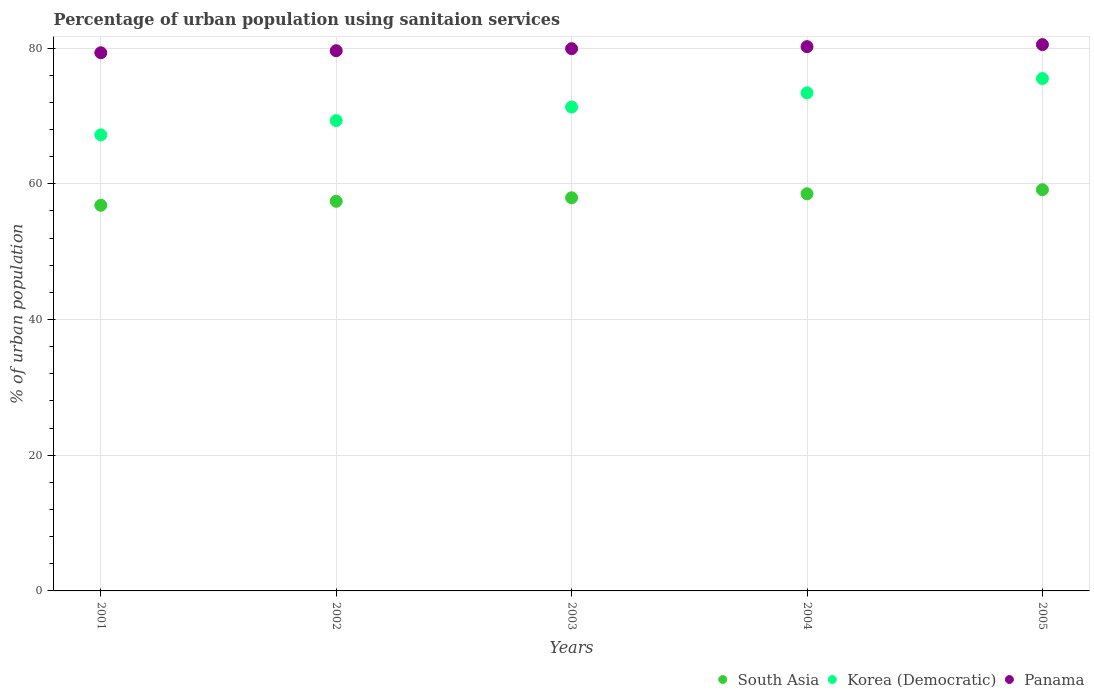How many different coloured dotlines are there?
Keep it short and to the point. 3. Is the number of dotlines equal to the number of legend labels?
Give a very brief answer. Yes. What is the percentage of urban population using sanitaion services in South Asia in 2002?
Your answer should be compact. 57.41. Across all years, what is the maximum percentage of urban population using sanitaion services in South Asia?
Offer a very short reply. 59.12. Across all years, what is the minimum percentage of urban population using sanitaion services in Panama?
Provide a succinct answer. 79.3. In which year was the percentage of urban population using sanitaion services in Panama maximum?
Offer a terse response. 2005. What is the total percentage of urban population using sanitaion services in Panama in the graph?
Provide a short and direct response. 399.5. What is the difference between the percentage of urban population using sanitaion services in South Asia in 2002 and that in 2005?
Your answer should be very brief. -1.71. What is the difference between the percentage of urban population using sanitaion services in South Asia in 2002 and the percentage of urban population using sanitaion services in Korea (Democratic) in 2005?
Your answer should be very brief. -18.09. What is the average percentage of urban population using sanitaion services in South Asia per year?
Your response must be concise. 57.96. In the year 2002, what is the difference between the percentage of urban population using sanitaion services in Panama and percentage of urban population using sanitaion services in Korea (Democratic)?
Ensure brevity in your answer.  10.3. In how many years, is the percentage of urban population using sanitaion services in Korea (Democratic) greater than 44 %?
Provide a short and direct response. 5. What is the ratio of the percentage of urban population using sanitaion services in South Asia in 2001 to that in 2003?
Make the answer very short. 0.98. Is the percentage of urban population using sanitaion services in Korea (Democratic) in 2003 less than that in 2004?
Provide a short and direct response. Yes. Is the difference between the percentage of urban population using sanitaion services in Panama in 2001 and 2002 greater than the difference between the percentage of urban population using sanitaion services in Korea (Democratic) in 2001 and 2002?
Offer a very short reply. Yes. What is the difference between the highest and the second highest percentage of urban population using sanitaion services in South Asia?
Give a very brief answer. 0.6. What is the difference between the highest and the lowest percentage of urban population using sanitaion services in Panama?
Your answer should be very brief. 1.2. Does the percentage of urban population using sanitaion services in Panama monotonically increase over the years?
Keep it short and to the point. Yes. Are the values on the major ticks of Y-axis written in scientific E-notation?
Ensure brevity in your answer.  No. Does the graph contain grids?
Your response must be concise. Yes. Where does the legend appear in the graph?
Provide a succinct answer. Bottom right. How many legend labels are there?
Make the answer very short. 3. What is the title of the graph?
Offer a terse response. Percentage of urban population using sanitaion services. Does "Guam" appear as one of the legend labels in the graph?
Your answer should be very brief. No. What is the label or title of the Y-axis?
Your answer should be compact. % of urban population. What is the % of urban population in South Asia in 2001?
Your response must be concise. 56.82. What is the % of urban population in Korea (Democratic) in 2001?
Give a very brief answer. 67.2. What is the % of urban population in Panama in 2001?
Your answer should be compact. 79.3. What is the % of urban population of South Asia in 2002?
Your response must be concise. 57.41. What is the % of urban population in Korea (Democratic) in 2002?
Make the answer very short. 69.3. What is the % of urban population in Panama in 2002?
Offer a terse response. 79.6. What is the % of urban population of South Asia in 2003?
Make the answer very short. 57.93. What is the % of urban population in Korea (Democratic) in 2003?
Your response must be concise. 71.3. What is the % of urban population in Panama in 2003?
Provide a short and direct response. 79.9. What is the % of urban population in South Asia in 2004?
Ensure brevity in your answer.  58.52. What is the % of urban population of Korea (Democratic) in 2004?
Provide a succinct answer. 73.4. What is the % of urban population of Panama in 2004?
Give a very brief answer. 80.2. What is the % of urban population in South Asia in 2005?
Give a very brief answer. 59.12. What is the % of urban population in Korea (Democratic) in 2005?
Offer a terse response. 75.5. What is the % of urban population in Panama in 2005?
Provide a succinct answer. 80.5. Across all years, what is the maximum % of urban population of South Asia?
Offer a terse response. 59.12. Across all years, what is the maximum % of urban population of Korea (Democratic)?
Your response must be concise. 75.5. Across all years, what is the maximum % of urban population in Panama?
Your answer should be compact. 80.5. Across all years, what is the minimum % of urban population in South Asia?
Provide a succinct answer. 56.82. Across all years, what is the minimum % of urban population of Korea (Democratic)?
Provide a short and direct response. 67.2. Across all years, what is the minimum % of urban population in Panama?
Make the answer very short. 79.3. What is the total % of urban population in South Asia in the graph?
Provide a short and direct response. 289.81. What is the total % of urban population of Korea (Democratic) in the graph?
Your answer should be compact. 356.7. What is the total % of urban population of Panama in the graph?
Ensure brevity in your answer.  399.5. What is the difference between the % of urban population in South Asia in 2001 and that in 2002?
Your answer should be very brief. -0.59. What is the difference between the % of urban population in South Asia in 2001 and that in 2003?
Your answer should be very brief. -1.1. What is the difference between the % of urban population in Korea (Democratic) in 2001 and that in 2003?
Give a very brief answer. -4.1. What is the difference between the % of urban population in South Asia in 2001 and that in 2004?
Keep it short and to the point. -1.7. What is the difference between the % of urban population of Korea (Democratic) in 2001 and that in 2004?
Your answer should be very brief. -6.2. What is the difference between the % of urban population of South Asia in 2001 and that in 2005?
Your answer should be compact. -2.29. What is the difference between the % of urban population in South Asia in 2002 and that in 2003?
Provide a short and direct response. -0.52. What is the difference between the % of urban population in Panama in 2002 and that in 2003?
Provide a succinct answer. -0.3. What is the difference between the % of urban population in South Asia in 2002 and that in 2004?
Ensure brevity in your answer.  -1.11. What is the difference between the % of urban population in Korea (Democratic) in 2002 and that in 2004?
Your response must be concise. -4.1. What is the difference between the % of urban population of Panama in 2002 and that in 2004?
Your answer should be very brief. -0.6. What is the difference between the % of urban population of South Asia in 2002 and that in 2005?
Offer a terse response. -1.71. What is the difference between the % of urban population of Korea (Democratic) in 2002 and that in 2005?
Your answer should be very brief. -6.2. What is the difference between the % of urban population of Panama in 2002 and that in 2005?
Offer a terse response. -0.9. What is the difference between the % of urban population of South Asia in 2003 and that in 2004?
Offer a very short reply. -0.59. What is the difference between the % of urban population of Korea (Democratic) in 2003 and that in 2004?
Give a very brief answer. -2.1. What is the difference between the % of urban population in South Asia in 2003 and that in 2005?
Your answer should be compact. -1.19. What is the difference between the % of urban population in Korea (Democratic) in 2003 and that in 2005?
Your answer should be compact. -4.2. What is the difference between the % of urban population in South Asia in 2004 and that in 2005?
Your answer should be very brief. -0.6. What is the difference between the % of urban population of Korea (Democratic) in 2004 and that in 2005?
Give a very brief answer. -2.1. What is the difference between the % of urban population of Panama in 2004 and that in 2005?
Offer a terse response. -0.3. What is the difference between the % of urban population of South Asia in 2001 and the % of urban population of Korea (Democratic) in 2002?
Keep it short and to the point. -12.48. What is the difference between the % of urban population of South Asia in 2001 and the % of urban population of Panama in 2002?
Your answer should be compact. -22.78. What is the difference between the % of urban population of South Asia in 2001 and the % of urban population of Korea (Democratic) in 2003?
Give a very brief answer. -14.48. What is the difference between the % of urban population of South Asia in 2001 and the % of urban population of Panama in 2003?
Your answer should be very brief. -23.08. What is the difference between the % of urban population in South Asia in 2001 and the % of urban population in Korea (Democratic) in 2004?
Offer a terse response. -16.58. What is the difference between the % of urban population of South Asia in 2001 and the % of urban population of Panama in 2004?
Your answer should be very brief. -23.38. What is the difference between the % of urban population in South Asia in 2001 and the % of urban population in Korea (Democratic) in 2005?
Ensure brevity in your answer.  -18.68. What is the difference between the % of urban population in South Asia in 2001 and the % of urban population in Panama in 2005?
Provide a short and direct response. -23.68. What is the difference between the % of urban population of Korea (Democratic) in 2001 and the % of urban population of Panama in 2005?
Give a very brief answer. -13.3. What is the difference between the % of urban population of South Asia in 2002 and the % of urban population of Korea (Democratic) in 2003?
Provide a succinct answer. -13.89. What is the difference between the % of urban population of South Asia in 2002 and the % of urban population of Panama in 2003?
Make the answer very short. -22.49. What is the difference between the % of urban population of Korea (Democratic) in 2002 and the % of urban population of Panama in 2003?
Provide a succinct answer. -10.6. What is the difference between the % of urban population of South Asia in 2002 and the % of urban population of Korea (Democratic) in 2004?
Provide a succinct answer. -15.99. What is the difference between the % of urban population in South Asia in 2002 and the % of urban population in Panama in 2004?
Your answer should be compact. -22.79. What is the difference between the % of urban population in South Asia in 2002 and the % of urban population in Korea (Democratic) in 2005?
Give a very brief answer. -18.09. What is the difference between the % of urban population in South Asia in 2002 and the % of urban population in Panama in 2005?
Ensure brevity in your answer.  -23.09. What is the difference between the % of urban population in South Asia in 2003 and the % of urban population in Korea (Democratic) in 2004?
Ensure brevity in your answer.  -15.47. What is the difference between the % of urban population in South Asia in 2003 and the % of urban population in Panama in 2004?
Your answer should be very brief. -22.27. What is the difference between the % of urban population in South Asia in 2003 and the % of urban population in Korea (Democratic) in 2005?
Keep it short and to the point. -17.57. What is the difference between the % of urban population of South Asia in 2003 and the % of urban population of Panama in 2005?
Your answer should be compact. -22.57. What is the difference between the % of urban population in South Asia in 2004 and the % of urban population in Korea (Democratic) in 2005?
Give a very brief answer. -16.98. What is the difference between the % of urban population of South Asia in 2004 and the % of urban population of Panama in 2005?
Give a very brief answer. -21.98. What is the average % of urban population in South Asia per year?
Provide a succinct answer. 57.96. What is the average % of urban population of Korea (Democratic) per year?
Make the answer very short. 71.34. What is the average % of urban population of Panama per year?
Provide a succinct answer. 79.9. In the year 2001, what is the difference between the % of urban population in South Asia and % of urban population in Korea (Democratic)?
Give a very brief answer. -10.38. In the year 2001, what is the difference between the % of urban population in South Asia and % of urban population in Panama?
Keep it short and to the point. -22.48. In the year 2001, what is the difference between the % of urban population of Korea (Democratic) and % of urban population of Panama?
Your answer should be compact. -12.1. In the year 2002, what is the difference between the % of urban population in South Asia and % of urban population in Korea (Democratic)?
Your answer should be compact. -11.89. In the year 2002, what is the difference between the % of urban population of South Asia and % of urban population of Panama?
Offer a terse response. -22.19. In the year 2003, what is the difference between the % of urban population of South Asia and % of urban population of Korea (Democratic)?
Give a very brief answer. -13.37. In the year 2003, what is the difference between the % of urban population in South Asia and % of urban population in Panama?
Make the answer very short. -21.97. In the year 2003, what is the difference between the % of urban population in Korea (Democratic) and % of urban population in Panama?
Keep it short and to the point. -8.6. In the year 2004, what is the difference between the % of urban population in South Asia and % of urban population in Korea (Democratic)?
Provide a short and direct response. -14.88. In the year 2004, what is the difference between the % of urban population of South Asia and % of urban population of Panama?
Ensure brevity in your answer.  -21.68. In the year 2004, what is the difference between the % of urban population in Korea (Democratic) and % of urban population in Panama?
Your response must be concise. -6.8. In the year 2005, what is the difference between the % of urban population of South Asia and % of urban population of Korea (Democratic)?
Give a very brief answer. -16.38. In the year 2005, what is the difference between the % of urban population of South Asia and % of urban population of Panama?
Offer a terse response. -21.38. What is the ratio of the % of urban population in South Asia in 2001 to that in 2002?
Give a very brief answer. 0.99. What is the ratio of the % of urban population in Korea (Democratic) in 2001 to that in 2002?
Provide a succinct answer. 0.97. What is the ratio of the % of urban population of South Asia in 2001 to that in 2003?
Provide a short and direct response. 0.98. What is the ratio of the % of urban population of Korea (Democratic) in 2001 to that in 2003?
Your answer should be compact. 0.94. What is the ratio of the % of urban population in Panama in 2001 to that in 2003?
Make the answer very short. 0.99. What is the ratio of the % of urban population of Korea (Democratic) in 2001 to that in 2004?
Offer a very short reply. 0.92. What is the ratio of the % of urban population in Panama in 2001 to that in 2004?
Your answer should be very brief. 0.99. What is the ratio of the % of urban population of South Asia in 2001 to that in 2005?
Your answer should be compact. 0.96. What is the ratio of the % of urban population of Korea (Democratic) in 2001 to that in 2005?
Your answer should be very brief. 0.89. What is the ratio of the % of urban population in Panama in 2001 to that in 2005?
Keep it short and to the point. 0.99. What is the ratio of the % of urban population in South Asia in 2002 to that in 2003?
Your answer should be very brief. 0.99. What is the ratio of the % of urban population in Korea (Democratic) in 2002 to that in 2003?
Your response must be concise. 0.97. What is the ratio of the % of urban population of Panama in 2002 to that in 2003?
Keep it short and to the point. 1. What is the ratio of the % of urban population of Korea (Democratic) in 2002 to that in 2004?
Give a very brief answer. 0.94. What is the ratio of the % of urban population in South Asia in 2002 to that in 2005?
Offer a terse response. 0.97. What is the ratio of the % of urban population of Korea (Democratic) in 2002 to that in 2005?
Your answer should be very brief. 0.92. What is the ratio of the % of urban population of Panama in 2002 to that in 2005?
Offer a terse response. 0.99. What is the ratio of the % of urban population in Korea (Democratic) in 2003 to that in 2004?
Provide a succinct answer. 0.97. What is the ratio of the % of urban population of Panama in 2003 to that in 2004?
Keep it short and to the point. 1. What is the ratio of the % of urban population of South Asia in 2003 to that in 2005?
Ensure brevity in your answer.  0.98. What is the ratio of the % of urban population in Panama in 2003 to that in 2005?
Offer a very short reply. 0.99. What is the ratio of the % of urban population in South Asia in 2004 to that in 2005?
Provide a succinct answer. 0.99. What is the ratio of the % of urban population in Korea (Democratic) in 2004 to that in 2005?
Make the answer very short. 0.97. What is the difference between the highest and the second highest % of urban population in South Asia?
Offer a very short reply. 0.6. What is the difference between the highest and the second highest % of urban population of Korea (Democratic)?
Your answer should be very brief. 2.1. What is the difference between the highest and the lowest % of urban population in South Asia?
Give a very brief answer. 2.29. What is the difference between the highest and the lowest % of urban population of Korea (Democratic)?
Your answer should be very brief. 8.3. What is the difference between the highest and the lowest % of urban population in Panama?
Your answer should be very brief. 1.2. 